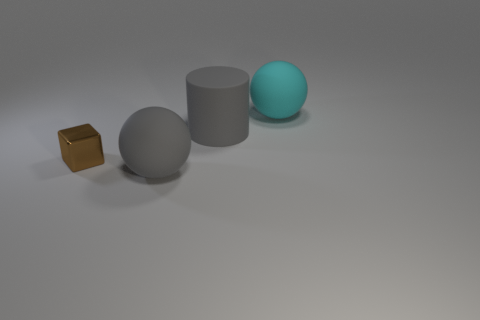Add 4 gray rubber objects. How many objects exist? 8 Subtract all blocks. How many objects are left? 3 Subtract 0 red spheres. How many objects are left? 4 Subtract all large objects. Subtract all large purple rubber balls. How many objects are left? 1 Add 2 tiny brown metallic objects. How many tiny brown metallic objects are left? 3 Add 1 yellow blocks. How many yellow blocks exist? 1 